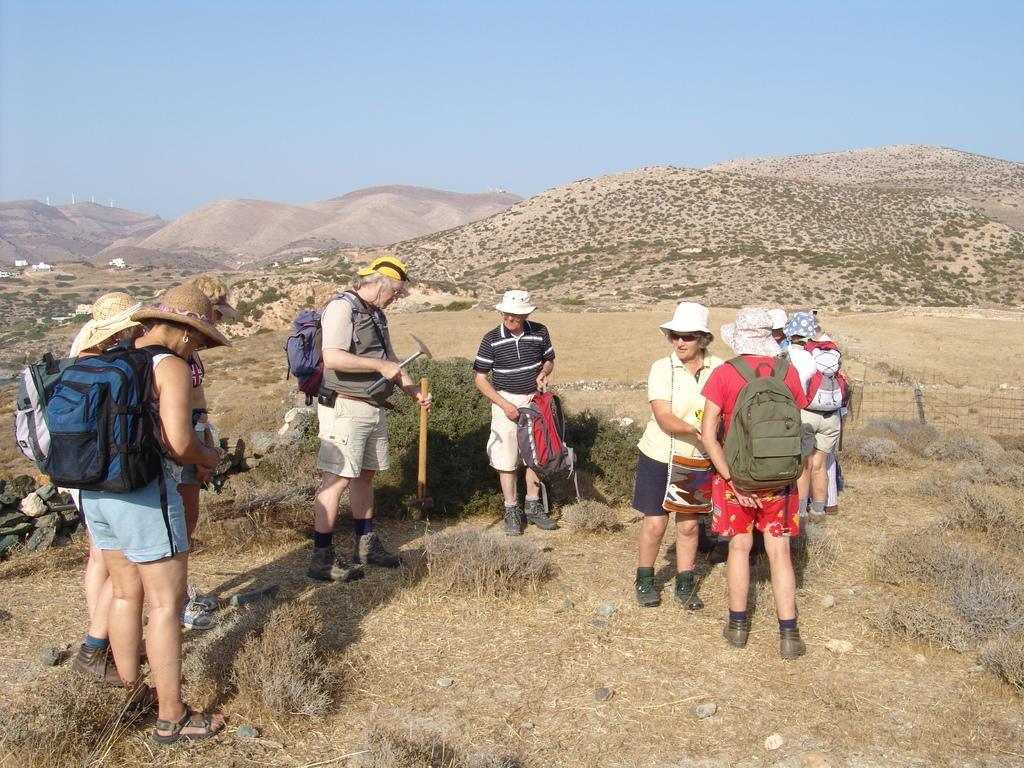What are the people in the image doing? The people in the image are carrying bags and holding objects. What can be seen in the background of the image? There are mountains and the sky visible in the background of the image. What type of clocks can be seen hanging from the mountains in the image? There are no clocks visible in the image, and the mountains are not mentioned as having any objects hanging from them. 